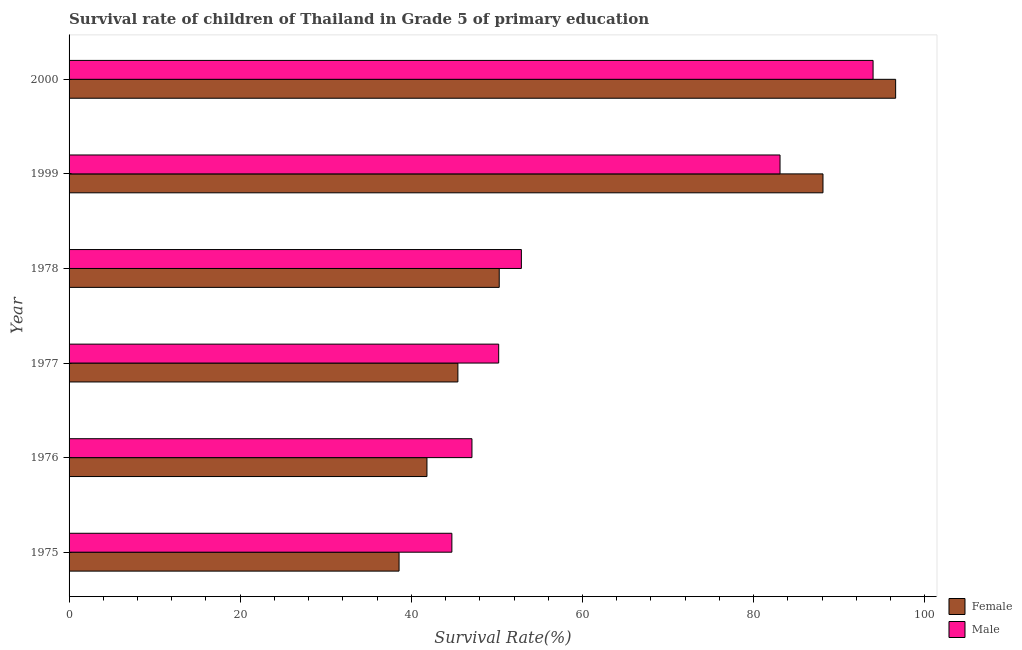How many different coloured bars are there?
Your response must be concise. 2. Are the number of bars per tick equal to the number of legend labels?
Offer a terse response. Yes. How many bars are there on the 6th tick from the bottom?
Offer a terse response. 2. What is the label of the 3rd group of bars from the top?
Make the answer very short. 1978. What is the survival rate of female students in primary education in 2000?
Your answer should be very brief. 96.59. Across all years, what is the maximum survival rate of male students in primary education?
Provide a short and direct response. 93.96. Across all years, what is the minimum survival rate of male students in primary education?
Make the answer very short. 44.73. In which year was the survival rate of female students in primary education maximum?
Make the answer very short. 2000. In which year was the survival rate of male students in primary education minimum?
Keep it short and to the point. 1975. What is the total survival rate of male students in primary education in the graph?
Keep it short and to the point. 371.91. What is the difference between the survival rate of male students in primary education in 1975 and that in 2000?
Ensure brevity in your answer.  -49.22. What is the difference between the survival rate of male students in primary education in 2000 and the survival rate of female students in primary education in 1999?
Your answer should be very brief. 5.85. What is the average survival rate of male students in primary education per year?
Keep it short and to the point. 61.98. In the year 2000, what is the difference between the survival rate of male students in primary education and survival rate of female students in primary education?
Make the answer very short. -2.64. What is the ratio of the survival rate of female students in primary education in 1999 to that in 2000?
Your response must be concise. 0.91. What is the difference between the highest and the second highest survival rate of male students in primary education?
Your response must be concise. 10.87. What is the difference between the highest and the lowest survival rate of male students in primary education?
Your answer should be very brief. 49.22. In how many years, is the survival rate of male students in primary education greater than the average survival rate of male students in primary education taken over all years?
Provide a short and direct response. 2. What does the 1st bar from the top in 1978 represents?
Your answer should be compact. Male. What does the 1st bar from the bottom in 2000 represents?
Offer a very short reply. Female. How many bars are there?
Make the answer very short. 12. How many years are there in the graph?
Offer a very short reply. 6. What is the difference between two consecutive major ticks on the X-axis?
Offer a terse response. 20. Are the values on the major ticks of X-axis written in scientific E-notation?
Provide a succinct answer. No. Does the graph contain any zero values?
Provide a short and direct response. No. How are the legend labels stacked?
Offer a terse response. Vertical. What is the title of the graph?
Your answer should be very brief. Survival rate of children of Thailand in Grade 5 of primary education. What is the label or title of the X-axis?
Provide a succinct answer. Survival Rate(%). What is the Survival Rate(%) of Female in 1975?
Make the answer very short. 38.56. What is the Survival Rate(%) in Male in 1975?
Give a very brief answer. 44.73. What is the Survival Rate(%) in Female in 1976?
Ensure brevity in your answer.  41.82. What is the Survival Rate(%) of Male in 1976?
Ensure brevity in your answer.  47.08. What is the Survival Rate(%) of Female in 1977?
Offer a very short reply. 45.44. What is the Survival Rate(%) of Male in 1977?
Your answer should be compact. 50.2. What is the Survival Rate(%) in Female in 1978?
Keep it short and to the point. 50.27. What is the Survival Rate(%) of Male in 1978?
Provide a succinct answer. 52.86. What is the Survival Rate(%) in Female in 1999?
Provide a short and direct response. 88.1. What is the Survival Rate(%) of Male in 1999?
Provide a short and direct response. 83.08. What is the Survival Rate(%) in Female in 2000?
Keep it short and to the point. 96.59. What is the Survival Rate(%) in Male in 2000?
Provide a succinct answer. 93.96. Across all years, what is the maximum Survival Rate(%) of Female?
Keep it short and to the point. 96.59. Across all years, what is the maximum Survival Rate(%) in Male?
Your response must be concise. 93.96. Across all years, what is the minimum Survival Rate(%) in Female?
Provide a succinct answer. 38.56. Across all years, what is the minimum Survival Rate(%) of Male?
Offer a terse response. 44.73. What is the total Survival Rate(%) in Female in the graph?
Your response must be concise. 360.79. What is the total Survival Rate(%) of Male in the graph?
Provide a short and direct response. 371.91. What is the difference between the Survival Rate(%) of Female in 1975 and that in 1976?
Your answer should be very brief. -3.26. What is the difference between the Survival Rate(%) in Male in 1975 and that in 1976?
Provide a short and direct response. -2.35. What is the difference between the Survival Rate(%) of Female in 1975 and that in 1977?
Offer a terse response. -6.87. What is the difference between the Survival Rate(%) in Male in 1975 and that in 1977?
Your answer should be very brief. -5.47. What is the difference between the Survival Rate(%) in Female in 1975 and that in 1978?
Your answer should be compact. -11.71. What is the difference between the Survival Rate(%) of Male in 1975 and that in 1978?
Provide a short and direct response. -8.12. What is the difference between the Survival Rate(%) of Female in 1975 and that in 1999?
Provide a succinct answer. -49.54. What is the difference between the Survival Rate(%) in Male in 1975 and that in 1999?
Make the answer very short. -38.35. What is the difference between the Survival Rate(%) of Female in 1975 and that in 2000?
Give a very brief answer. -58.03. What is the difference between the Survival Rate(%) of Male in 1975 and that in 2000?
Your response must be concise. -49.22. What is the difference between the Survival Rate(%) of Female in 1976 and that in 1977?
Offer a terse response. -3.61. What is the difference between the Survival Rate(%) in Male in 1976 and that in 1977?
Your answer should be very brief. -3.12. What is the difference between the Survival Rate(%) of Female in 1976 and that in 1978?
Your answer should be compact. -8.45. What is the difference between the Survival Rate(%) in Male in 1976 and that in 1978?
Offer a very short reply. -5.78. What is the difference between the Survival Rate(%) of Female in 1976 and that in 1999?
Make the answer very short. -46.28. What is the difference between the Survival Rate(%) in Male in 1976 and that in 1999?
Offer a terse response. -36. What is the difference between the Survival Rate(%) of Female in 1976 and that in 2000?
Give a very brief answer. -54.77. What is the difference between the Survival Rate(%) in Male in 1976 and that in 2000?
Make the answer very short. -46.88. What is the difference between the Survival Rate(%) in Female in 1977 and that in 1978?
Offer a very short reply. -4.83. What is the difference between the Survival Rate(%) in Male in 1977 and that in 1978?
Keep it short and to the point. -2.65. What is the difference between the Survival Rate(%) of Female in 1977 and that in 1999?
Your answer should be compact. -42.67. What is the difference between the Survival Rate(%) in Male in 1977 and that in 1999?
Provide a short and direct response. -32.88. What is the difference between the Survival Rate(%) in Female in 1977 and that in 2000?
Your response must be concise. -51.16. What is the difference between the Survival Rate(%) of Male in 1977 and that in 2000?
Ensure brevity in your answer.  -43.75. What is the difference between the Survival Rate(%) in Female in 1978 and that in 1999?
Offer a very short reply. -37.83. What is the difference between the Survival Rate(%) in Male in 1978 and that in 1999?
Your answer should be compact. -30.23. What is the difference between the Survival Rate(%) of Female in 1978 and that in 2000?
Offer a terse response. -46.32. What is the difference between the Survival Rate(%) in Male in 1978 and that in 2000?
Ensure brevity in your answer.  -41.1. What is the difference between the Survival Rate(%) of Female in 1999 and that in 2000?
Provide a succinct answer. -8.49. What is the difference between the Survival Rate(%) of Male in 1999 and that in 2000?
Keep it short and to the point. -10.87. What is the difference between the Survival Rate(%) of Female in 1975 and the Survival Rate(%) of Male in 1976?
Make the answer very short. -8.52. What is the difference between the Survival Rate(%) of Female in 1975 and the Survival Rate(%) of Male in 1977?
Your response must be concise. -11.64. What is the difference between the Survival Rate(%) of Female in 1975 and the Survival Rate(%) of Male in 1978?
Offer a very short reply. -14.29. What is the difference between the Survival Rate(%) in Female in 1975 and the Survival Rate(%) in Male in 1999?
Give a very brief answer. -44.52. What is the difference between the Survival Rate(%) in Female in 1975 and the Survival Rate(%) in Male in 2000?
Your answer should be very brief. -55.39. What is the difference between the Survival Rate(%) in Female in 1976 and the Survival Rate(%) in Male in 1977?
Provide a succinct answer. -8.38. What is the difference between the Survival Rate(%) in Female in 1976 and the Survival Rate(%) in Male in 1978?
Offer a terse response. -11.03. What is the difference between the Survival Rate(%) in Female in 1976 and the Survival Rate(%) in Male in 1999?
Give a very brief answer. -41.26. What is the difference between the Survival Rate(%) in Female in 1976 and the Survival Rate(%) in Male in 2000?
Keep it short and to the point. -52.13. What is the difference between the Survival Rate(%) in Female in 1977 and the Survival Rate(%) in Male in 1978?
Provide a succinct answer. -7.42. What is the difference between the Survival Rate(%) of Female in 1977 and the Survival Rate(%) of Male in 1999?
Keep it short and to the point. -37.65. What is the difference between the Survival Rate(%) of Female in 1977 and the Survival Rate(%) of Male in 2000?
Offer a very short reply. -48.52. What is the difference between the Survival Rate(%) in Female in 1978 and the Survival Rate(%) in Male in 1999?
Your answer should be very brief. -32.81. What is the difference between the Survival Rate(%) in Female in 1978 and the Survival Rate(%) in Male in 2000?
Provide a succinct answer. -43.69. What is the difference between the Survival Rate(%) in Female in 1999 and the Survival Rate(%) in Male in 2000?
Your response must be concise. -5.85. What is the average Survival Rate(%) in Female per year?
Offer a very short reply. 60.13. What is the average Survival Rate(%) in Male per year?
Make the answer very short. 61.99. In the year 1975, what is the difference between the Survival Rate(%) in Female and Survival Rate(%) in Male?
Keep it short and to the point. -6.17. In the year 1976, what is the difference between the Survival Rate(%) of Female and Survival Rate(%) of Male?
Offer a very short reply. -5.26. In the year 1977, what is the difference between the Survival Rate(%) in Female and Survival Rate(%) in Male?
Give a very brief answer. -4.77. In the year 1978, what is the difference between the Survival Rate(%) of Female and Survival Rate(%) of Male?
Keep it short and to the point. -2.59. In the year 1999, what is the difference between the Survival Rate(%) of Female and Survival Rate(%) of Male?
Offer a very short reply. 5.02. In the year 2000, what is the difference between the Survival Rate(%) in Female and Survival Rate(%) in Male?
Ensure brevity in your answer.  2.64. What is the ratio of the Survival Rate(%) in Female in 1975 to that in 1976?
Offer a terse response. 0.92. What is the ratio of the Survival Rate(%) of Male in 1975 to that in 1976?
Offer a terse response. 0.95. What is the ratio of the Survival Rate(%) of Female in 1975 to that in 1977?
Ensure brevity in your answer.  0.85. What is the ratio of the Survival Rate(%) of Male in 1975 to that in 1977?
Your answer should be compact. 0.89. What is the ratio of the Survival Rate(%) of Female in 1975 to that in 1978?
Offer a very short reply. 0.77. What is the ratio of the Survival Rate(%) of Male in 1975 to that in 1978?
Keep it short and to the point. 0.85. What is the ratio of the Survival Rate(%) of Female in 1975 to that in 1999?
Give a very brief answer. 0.44. What is the ratio of the Survival Rate(%) in Male in 1975 to that in 1999?
Provide a short and direct response. 0.54. What is the ratio of the Survival Rate(%) in Female in 1975 to that in 2000?
Give a very brief answer. 0.4. What is the ratio of the Survival Rate(%) of Male in 1975 to that in 2000?
Make the answer very short. 0.48. What is the ratio of the Survival Rate(%) in Female in 1976 to that in 1977?
Offer a very short reply. 0.92. What is the ratio of the Survival Rate(%) of Male in 1976 to that in 1977?
Your answer should be very brief. 0.94. What is the ratio of the Survival Rate(%) of Female in 1976 to that in 1978?
Ensure brevity in your answer.  0.83. What is the ratio of the Survival Rate(%) of Male in 1976 to that in 1978?
Your answer should be very brief. 0.89. What is the ratio of the Survival Rate(%) in Female in 1976 to that in 1999?
Your response must be concise. 0.47. What is the ratio of the Survival Rate(%) in Male in 1976 to that in 1999?
Your answer should be compact. 0.57. What is the ratio of the Survival Rate(%) of Female in 1976 to that in 2000?
Provide a short and direct response. 0.43. What is the ratio of the Survival Rate(%) in Male in 1976 to that in 2000?
Your answer should be very brief. 0.5. What is the ratio of the Survival Rate(%) of Female in 1977 to that in 1978?
Your response must be concise. 0.9. What is the ratio of the Survival Rate(%) in Male in 1977 to that in 1978?
Give a very brief answer. 0.95. What is the ratio of the Survival Rate(%) in Female in 1977 to that in 1999?
Your response must be concise. 0.52. What is the ratio of the Survival Rate(%) of Male in 1977 to that in 1999?
Provide a succinct answer. 0.6. What is the ratio of the Survival Rate(%) of Female in 1977 to that in 2000?
Your answer should be very brief. 0.47. What is the ratio of the Survival Rate(%) in Male in 1977 to that in 2000?
Your answer should be very brief. 0.53. What is the ratio of the Survival Rate(%) in Female in 1978 to that in 1999?
Offer a terse response. 0.57. What is the ratio of the Survival Rate(%) of Male in 1978 to that in 1999?
Your response must be concise. 0.64. What is the ratio of the Survival Rate(%) of Female in 1978 to that in 2000?
Give a very brief answer. 0.52. What is the ratio of the Survival Rate(%) of Male in 1978 to that in 2000?
Offer a terse response. 0.56. What is the ratio of the Survival Rate(%) in Female in 1999 to that in 2000?
Keep it short and to the point. 0.91. What is the ratio of the Survival Rate(%) of Male in 1999 to that in 2000?
Offer a very short reply. 0.88. What is the difference between the highest and the second highest Survival Rate(%) of Female?
Provide a succinct answer. 8.49. What is the difference between the highest and the second highest Survival Rate(%) in Male?
Give a very brief answer. 10.87. What is the difference between the highest and the lowest Survival Rate(%) in Female?
Offer a terse response. 58.03. What is the difference between the highest and the lowest Survival Rate(%) in Male?
Give a very brief answer. 49.22. 